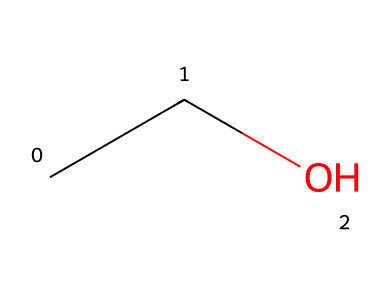What is the number of carbon atoms in this chemical? The chemical composition CC means there are 2 carbon atoms in the structure.
Answer: 2 How many oxygen atoms are present in this structure? In the SMILES representation, the 'O' indicates that there is 1 oxygen atom.
Answer: 1 What is the name of this chemical? The structure represented by CC(O) is known as ethanol, which can be identified by looking at its SMILES notation and recognizing the functional group at the end.
Answer: ethanol Is this chemical a primary alcohol? The presence of one hydroxyl (-OH) group and the carbon it is attached to confirms that it is a primary alcohol, which has the hydroxyl group on the end carbon.
Answer: yes What is the degree of saturation of this chemical? The formula C2H6O shows that there are enough hydrogens to saturate the carbon chain, indicating there are no double or triple bonds, thus it is fully saturated.
Answer: saturated What is the typical use of this chemical in biofuels? Ethanol is commonly used as a biofuel due to its properties as an alcohol that can be blended with gasoline for cleaner combustion.
Answer: biofuel How many hydrogen atoms are in ethanol? The SMILES representation CC indicates there are 6 hydrogen atoms when counted with the structure's complete formula (C2H6O).
Answer: 6 